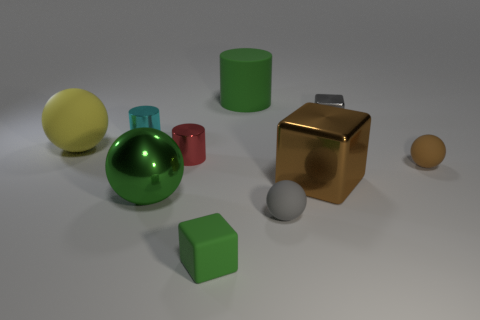Could these objects convey any educational value? Certainly, this assortment of objects could serve as an educational tool. For example, they can be used for teaching basic geometry by comparing their shapes, sizes, and volumes, or for discussing material properties such as reflectivity, texture, and color. Would the size ratio between these objects be consistent with real-world objects? Not necessarily; the image appears to present a scaled-down or abstract collection that does not correspond to standard real-world dimensions. The objects may be intentionally proportioned to demonstrate concepts such as relative size and scale or to create an aesthetically pleasing arrangement. 